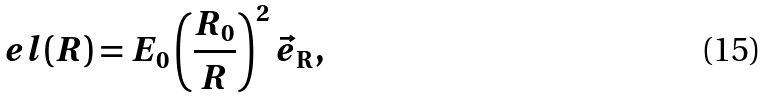<formula> <loc_0><loc_0><loc_500><loc_500>\ e l ( R ) = E _ { 0 } \left ( \frac { R _ { 0 } } { R } \right ) ^ { 2 } \vec { e } _ { \mathrm R } ,</formula> 